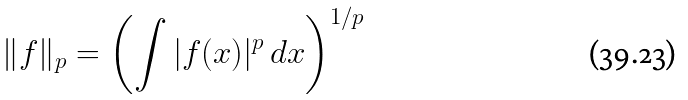<formula> <loc_0><loc_0><loc_500><loc_500>\| f \| _ { p } = \left ( \int | f ( x ) | ^ { p } \, d x \right ) ^ { 1 / p }</formula> 